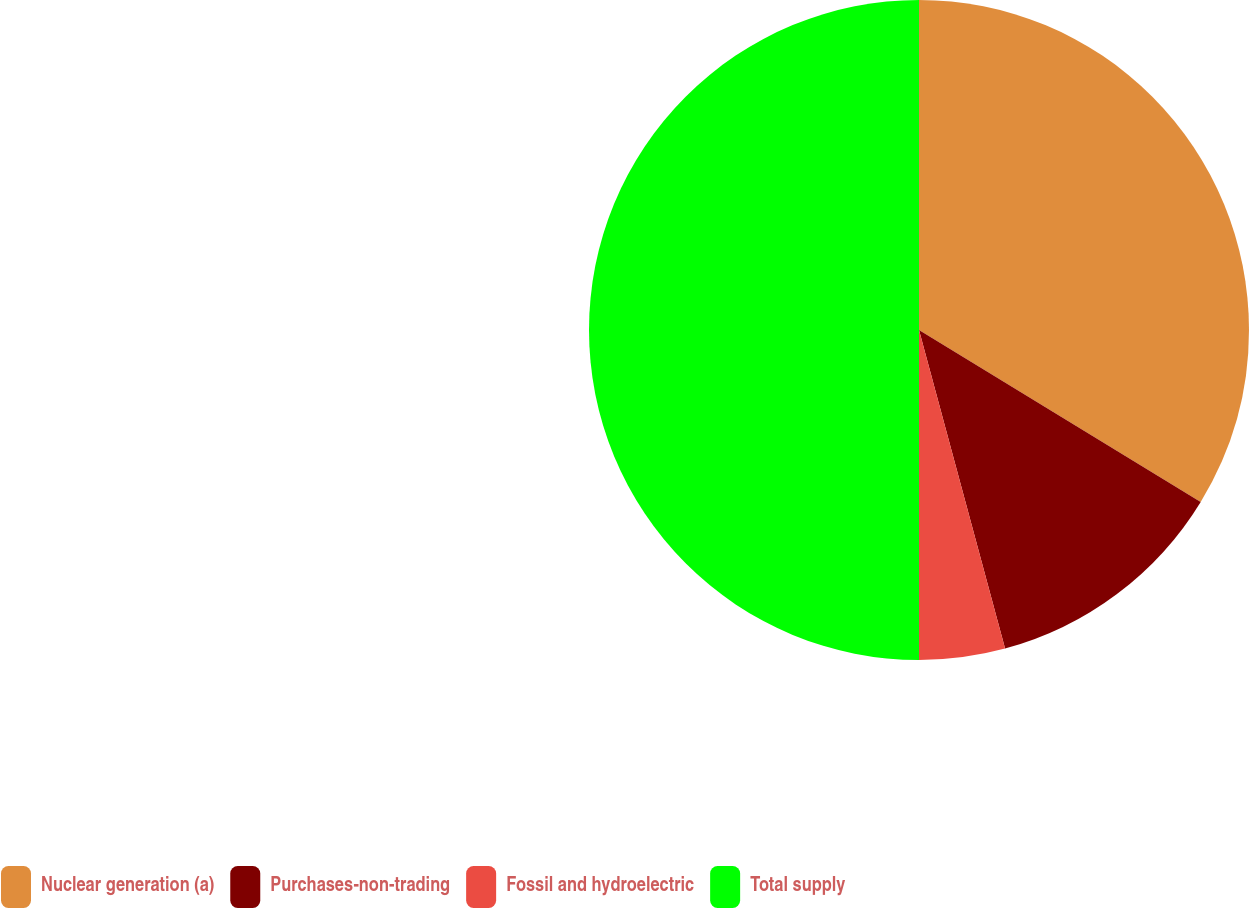<chart> <loc_0><loc_0><loc_500><loc_500><pie_chart><fcel>Nuclear generation (a)<fcel>Purchases-non-trading<fcel>Fossil and hydroelectric<fcel>Total supply<nl><fcel>33.72%<fcel>12.08%<fcel>4.2%<fcel>50.0%<nl></chart> 